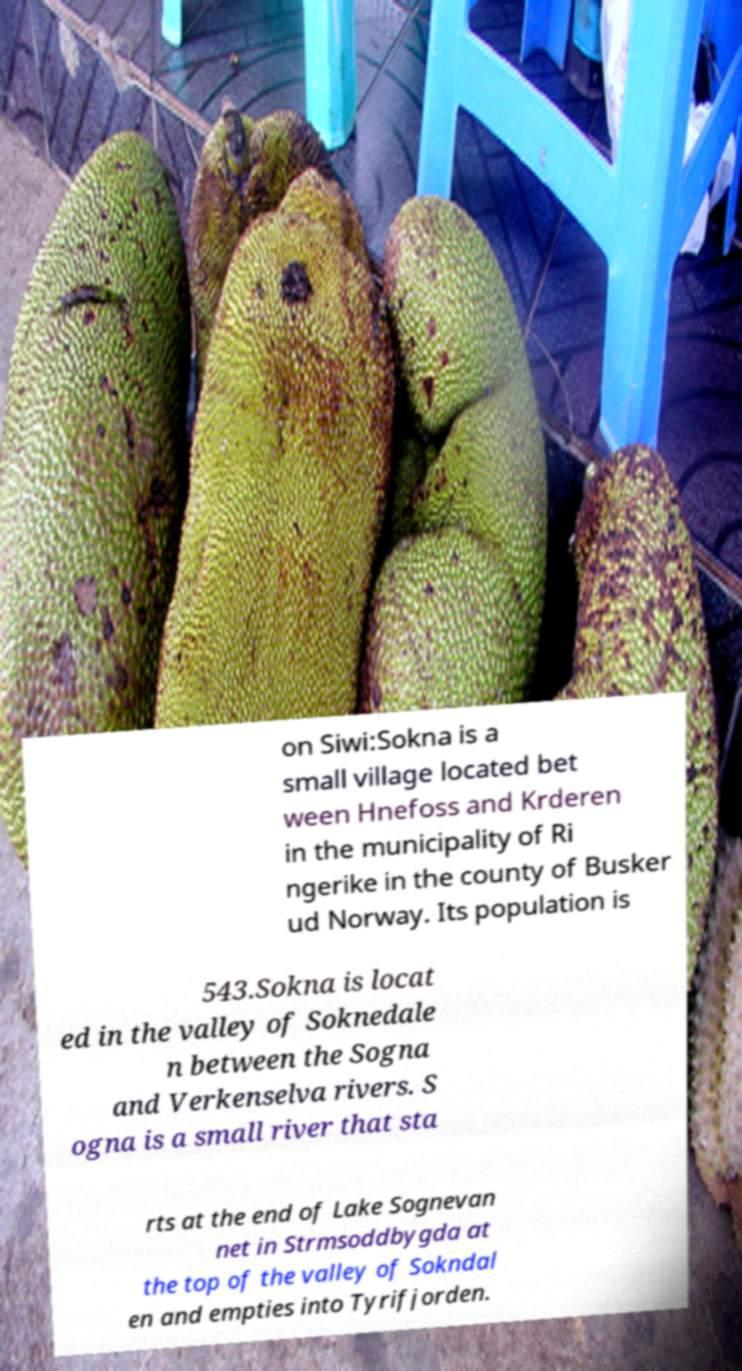Please read and relay the text visible in this image. What does it say? on Siwi:Sokna is a small village located bet ween Hnefoss and Krderen in the municipality of Ri ngerike in the county of Busker ud Norway. Its population is 543.Sokna is locat ed in the valley of Soknedale n between the Sogna and Verkenselva rivers. S ogna is a small river that sta rts at the end of Lake Sognevan net in Strmsoddbygda at the top of the valley of Sokndal en and empties into Tyrifjorden. 